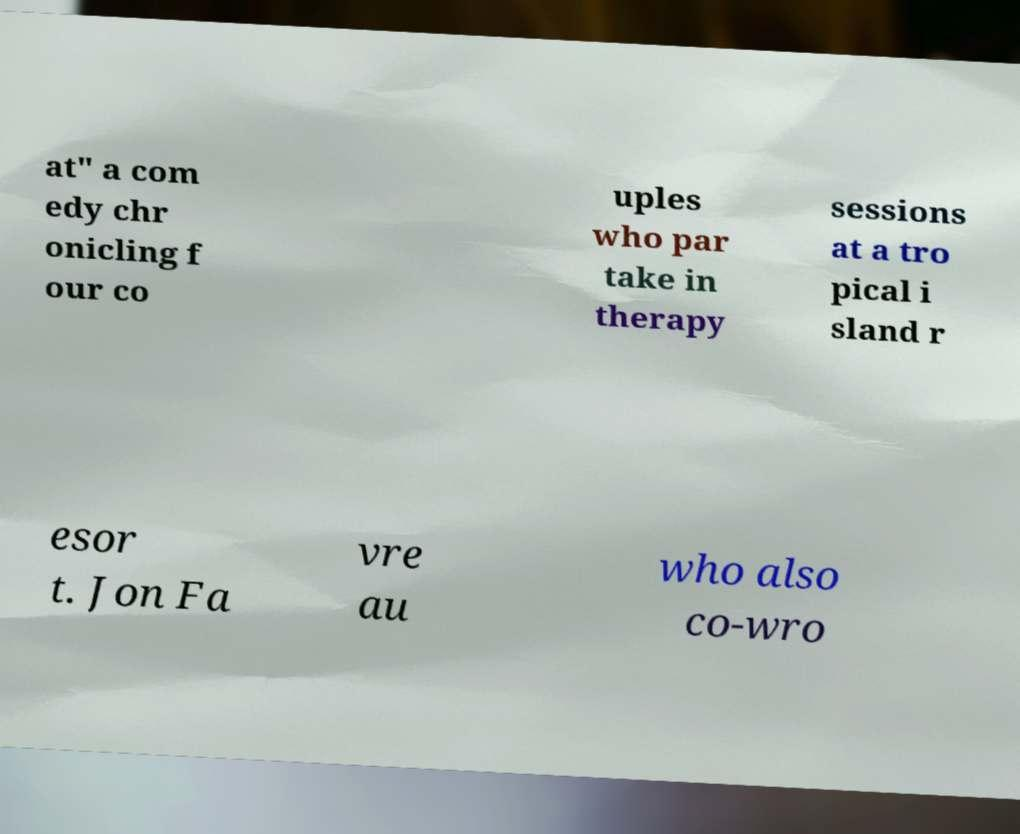What messages or text are displayed in this image? I need them in a readable, typed format. at" a com edy chr onicling f our co uples who par take in therapy sessions at a tro pical i sland r esor t. Jon Fa vre au who also co-wro 